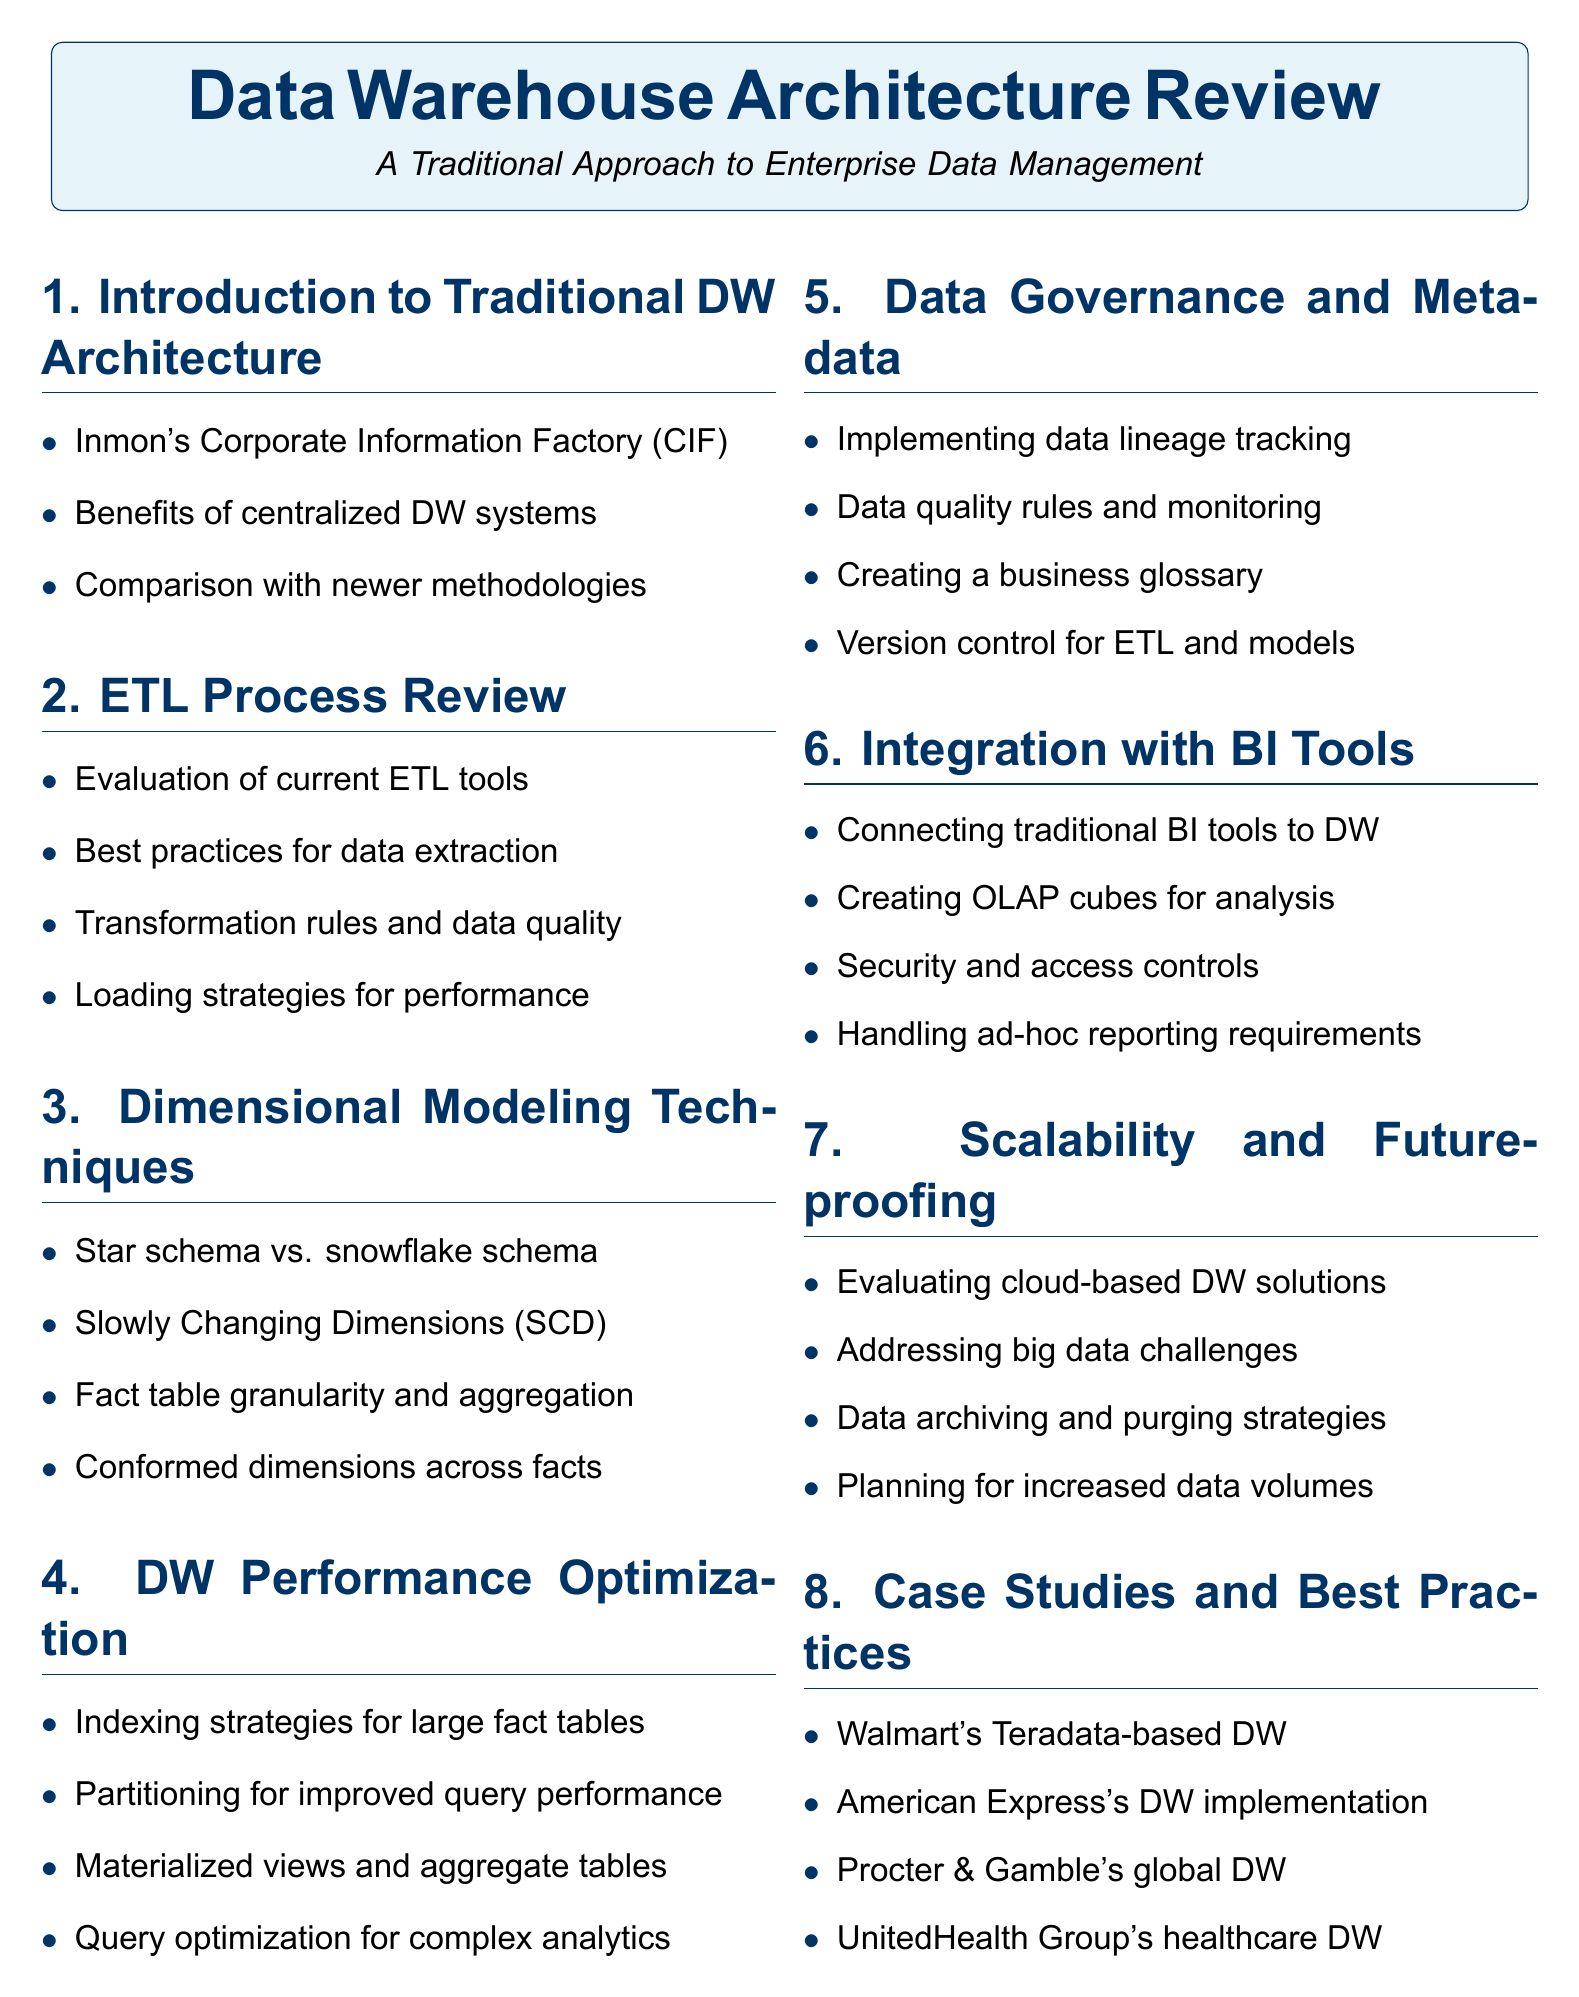What is Inmon's approach to data warehousing? Inmon's approach is referred to as the Corporate Information Factory (CIF).
Answer: Corporate Information Factory (CIF) Which ETL tool is mentioned for evaluation? The document mentions IBM InfoSphere DataStage as one of the current ETL tools under evaluation.
Answer: IBM InfoSphere DataStage What are the two types of schema discussed in dimensional modeling? The document discusses star schema and snowflake schema as types of dimensional modeling techniques.
Answer: Star schema and snowflake schema What strategy is suggested for improving query performance? Partitioning schemes are suggested for improved query performance in the data warehouse.
Answer: Partitioning schemes What type of cubes are created for multidimensional analysis? The document states that OLAP cubes are created for multidimensional analysis.
Answer: OLAP cubes What is one of the key focuses of data governance? Implementing data lineage tracking is a key focus of data governance as per the document.
Answer: Data lineage tracking Which company's data warehouse is cited as a success story? Walmart's Teradata-based data warehouse is cited as a success story in the document.
Answer: Walmart's Teradata-based data warehouse What document section addresses scalability and future-proofing? The section that addresses scalability and future-proofing is titled "Scalability and Future-proofing."
Answer: Scalability and Future-proofing How many case studies are included in the document? The document includes four case studies in the section titled "Case Studies and Best Practices."
Answer: Four 